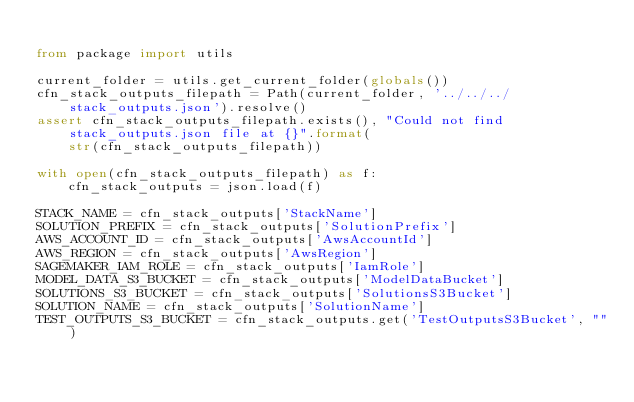<code> <loc_0><loc_0><loc_500><loc_500><_Python_>
from package import utils

current_folder = utils.get_current_folder(globals())
cfn_stack_outputs_filepath = Path(current_folder, '../../../stack_outputs.json').resolve()
assert cfn_stack_outputs_filepath.exists(), "Could not find stack_outputs.json file at {}".format(
    str(cfn_stack_outputs_filepath))

with open(cfn_stack_outputs_filepath) as f:
    cfn_stack_outputs = json.load(f)

STACK_NAME = cfn_stack_outputs['StackName']
SOLUTION_PREFIX = cfn_stack_outputs['SolutionPrefix']
AWS_ACCOUNT_ID = cfn_stack_outputs['AwsAccountId']
AWS_REGION = cfn_stack_outputs['AwsRegion']
SAGEMAKER_IAM_ROLE = cfn_stack_outputs['IamRole']
MODEL_DATA_S3_BUCKET = cfn_stack_outputs['ModelDataBucket']
SOLUTIONS_S3_BUCKET = cfn_stack_outputs['SolutionsS3Bucket']
SOLUTION_NAME = cfn_stack_outputs['SolutionName']
TEST_OUTPUTS_S3_BUCKET = cfn_stack_outputs.get('TestOutputsS3Bucket', "")
</code> 